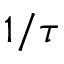<formula> <loc_0><loc_0><loc_500><loc_500>1 / \tau</formula> 